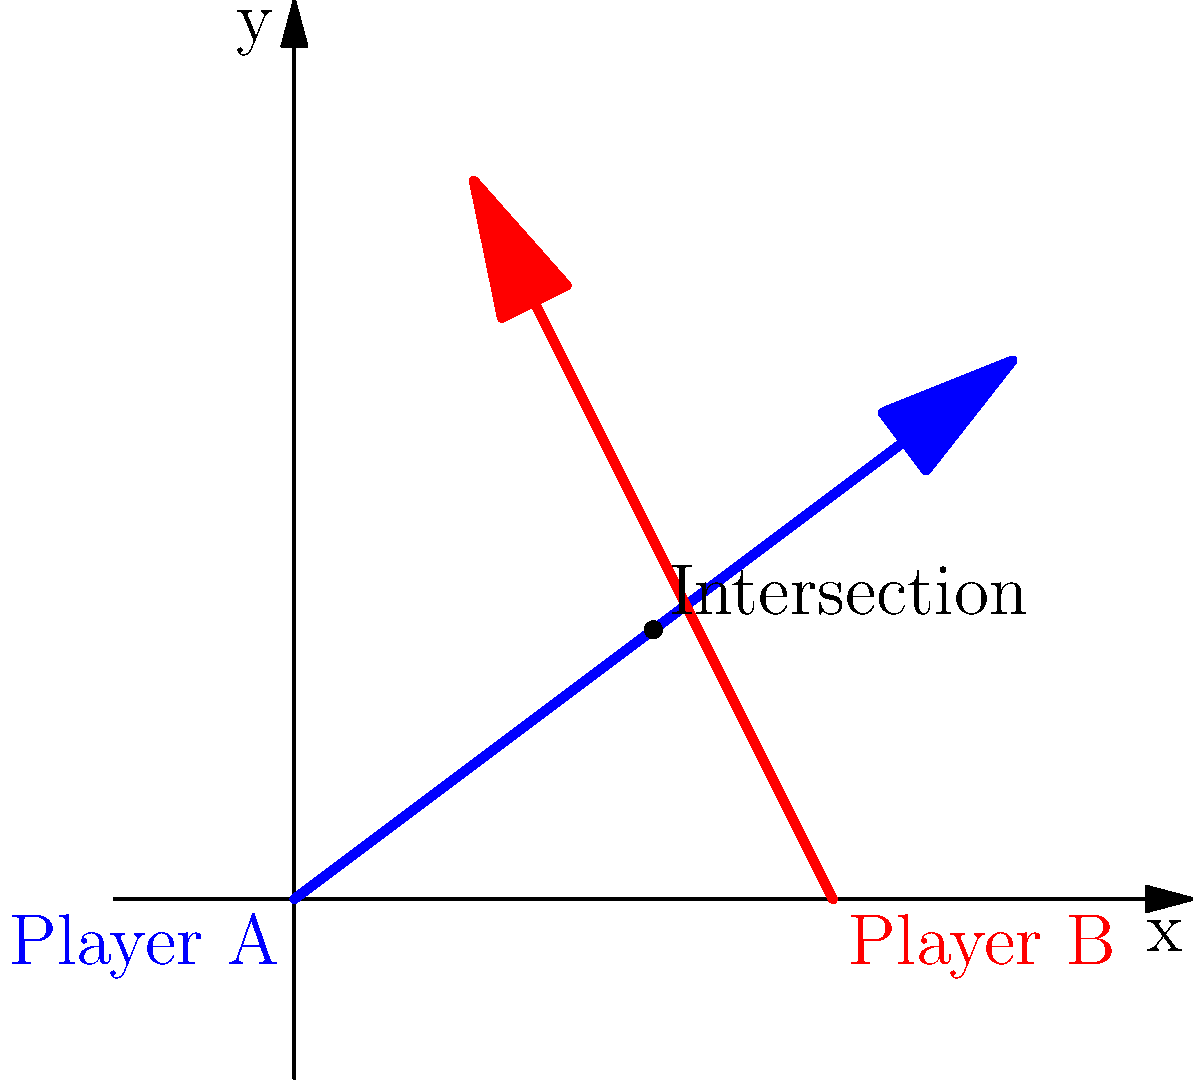During a Penn State Nittany Lions ice hockey game, Player A starts skating from the point (0,0) towards the point (8,6), while Player B starts from (6,0) and skates towards (2,8). At what coordinates do their paths intersect? To find the intersection point, we need to:

1) Find the equations of both lines representing the players' paths.
2) Solve these equations simultaneously.

For Player A:
Slope $m_A = \frac{6-0}{8-0} = \frac{3}{4}$
Equation: $y = \frac{3}{4}x$

For Player B:
Slope $m_B = \frac{8-0}{2-6} = -2$
Equation: $y = -2(x-6)$ or $y = -2x + 12$

Now, let's equate these:

$\frac{3}{4}x = -2x + 12$

$\frac{11}{4}x = 12$

$x = \frac{48}{11} = 4\frac{4}{11} \approx 4$

Substituting this x-value into either equation:

$y = \frac{3}{4}(4) = 3$

Therefore, the paths intersect at the point $(4,3)$.
Answer: $(4,3)$ 